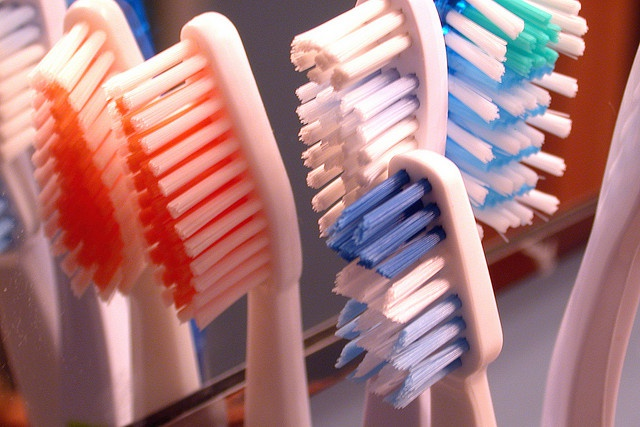Describe the objects in this image and their specific colors. I can see toothbrush in lightpink, brown, white, and salmon tones, toothbrush in lightpink, lightgray, gray, and purple tones, toothbrush in lightpink, brown, white, and salmon tones, toothbrush in lightpink, white, salmon, and purple tones, and toothbrush in lightpink, brown, and pink tones in this image. 